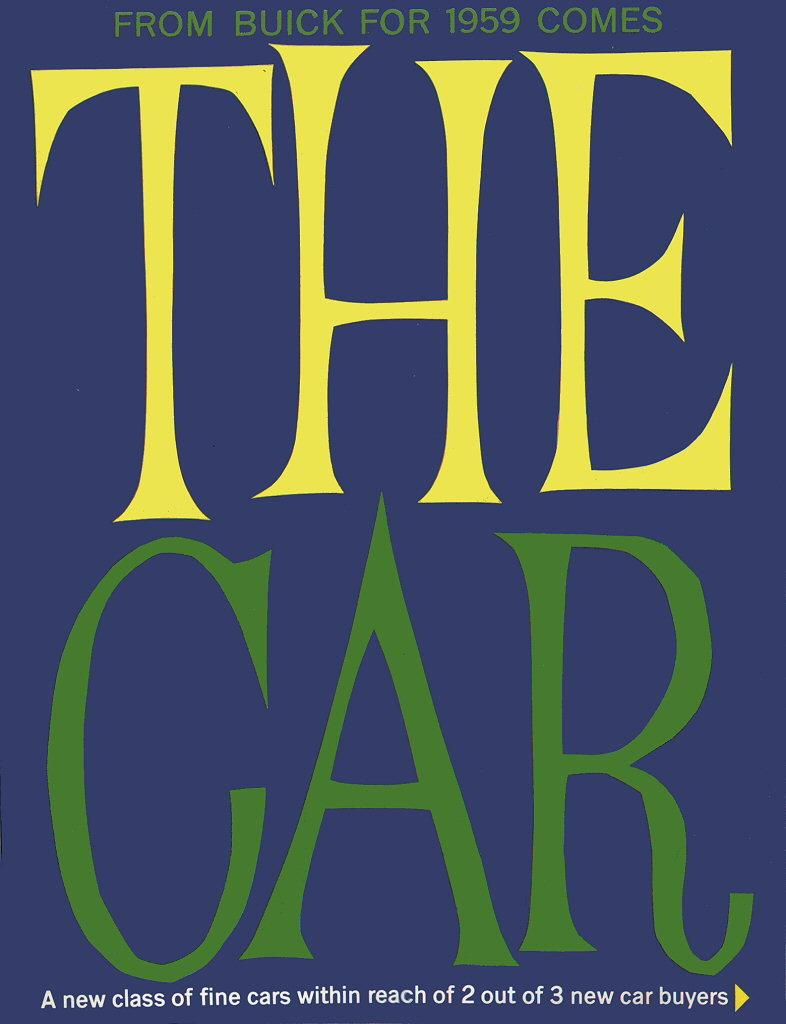<image>
Give a short and clear explanation of the subsequent image. An advertisement for Buick cars from 1959 that says THE CAR. 